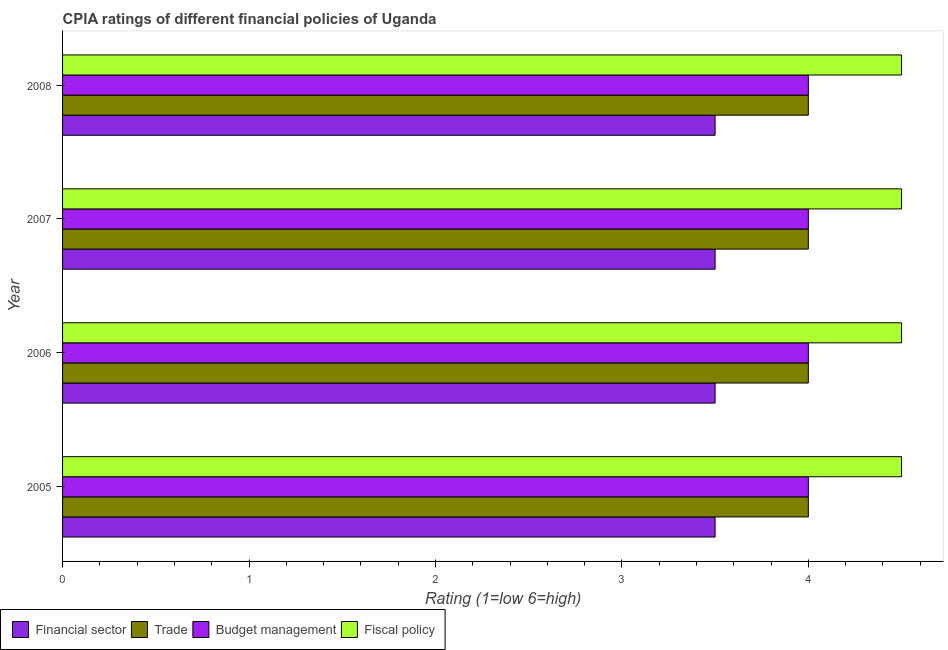How many groups of bars are there?
Offer a very short reply. 4. What is the label of the 2nd group of bars from the top?
Ensure brevity in your answer.  2007. What is the cpia rating of fiscal policy in 2007?
Offer a terse response. 4.5. Across all years, what is the minimum cpia rating of fiscal policy?
Give a very brief answer. 4.5. In which year was the cpia rating of financial sector maximum?
Your response must be concise. 2005. What is the average cpia rating of budget management per year?
Ensure brevity in your answer.  4. In the year 2006, what is the difference between the cpia rating of trade and cpia rating of financial sector?
Provide a succinct answer. 0.5. Is the cpia rating of financial sector in 2005 less than that in 2008?
Your answer should be very brief. No. Is the difference between the cpia rating of financial sector in 2006 and 2008 greater than the difference between the cpia rating of trade in 2006 and 2008?
Your response must be concise. No. What is the difference between the highest and the second highest cpia rating of trade?
Ensure brevity in your answer.  0. In how many years, is the cpia rating of financial sector greater than the average cpia rating of financial sector taken over all years?
Your answer should be compact. 0. What does the 3rd bar from the top in 2005 represents?
Your answer should be compact. Trade. What does the 4th bar from the bottom in 2006 represents?
Offer a terse response. Fiscal policy. How many bars are there?
Your answer should be very brief. 16. Are all the bars in the graph horizontal?
Keep it short and to the point. Yes. How many years are there in the graph?
Offer a very short reply. 4. Does the graph contain any zero values?
Give a very brief answer. No. Where does the legend appear in the graph?
Your answer should be very brief. Bottom left. How many legend labels are there?
Your answer should be compact. 4. How are the legend labels stacked?
Provide a succinct answer. Horizontal. What is the title of the graph?
Provide a short and direct response. CPIA ratings of different financial policies of Uganda. What is the label or title of the X-axis?
Keep it short and to the point. Rating (1=low 6=high). What is the Rating (1=low 6=high) of Financial sector in 2005?
Provide a succinct answer. 3.5. What is the Rating (1=low 6=high) of Budget management in 2005?
Offer a terse response. 4. What is the Rating (1=low 6=high) in Fiscal policy in 2005?
Provide a succinct answer. 4.5. What is the Rating (1=low 6=high) in Financial sector in 2007?
Your response must be concise. 3.5. What is the Rating (1=low 6=high) of Trade in 2007?
Your answer should be very brief. 4. What is the Rating (1=low 6=high) in Fiscal policy in 2007?
Keep it short and to the point. 4.5. What is the Rating (1=low 6=high) in Budget management in 2008?
Provide a short and direct response. 4. What is the Rating (1=low 6=high) in Fiscal policy in 2008?
Give a very brief answer. 4.5. Across all years, what is the maximum Rating (1=low 6=high) of Financial sector?
Your response must be concise. 3.5. Across all years, what is the maximum Rating (1=low 6=high) of Trade?
Make the answer very short. 4. Across all years, what is the maximum Rating (1=low 6=high) of Budget management?
Keep it short and to the point. 4. Across all years, what is the maximum Rating (1=low 6=high) in Fiscal policy?
Your answer should be compact. 4.5. Across all years, what is the minimum Rating (1=low 6=high) in Budget management?
Your response must be concise. 4. Across all years, what is the minimum Rating (1=low 6=high) in Fiscal policy?
Make the answer very short. 4.5. What is the total Rating (1=low 6=high) in Budget management in the graph?
Your response must be concise. 16. What is the total Rating (1=low 6=high) of Fiscal policy in the graph?
Ensure brevity in your answer.  18. What is the difference between the Rating (1=low 6=high) of Trade in 2005 and that in 2006?
Your response must be concise. 0. What is the difference between the Rating (1=low 6=high) in Budget management in 2005 and that in 2006?
Provide a short and direct response. 0. What is the difference between the Rating (1=low 6=high) of Financial sector in 2005 and that in 2008?
Your answer should be compact. 0. What is the difference between the Rating (1=low 6=high) in Trade in 2005 and that in 2008?
Make the answer very short. 0. What is the difference between the Rating (1=low 6=high) of Budget management in 2005 and that in 2008?
Keep it short and to the point. 0. What is the difference between the Rating (1=low 6=high) in Financial sector in 2006 and that in 2007?
Make the answer very short. 0. What is the difference between the Rating (1=low 6=high) of Trade in 2006 and that in 2007?
Make the answer very short. 0. What is the difference between the Rating (1=low 6=high) in Fiscal policy in 2006 and that in 2007?
Ensure brevity in your answer.  0. What is the difference between the Rating (1=low 6=high) of Budget management in 2006 and that in 2008?
Keep it short and to the point. 0. What is the difference between the Rating (1=low 6=high) in Financial sector in 2007 and that in 2008?
Ensure brevity in your answer.  0. What is the difference between the Rating (1=low 6=high) of Budget management in 2007 and that in 2008?
Provide a short and direct response. 0. What is the difference between the Rating (1=low 6=high) in Fiscal policy in 2007 and that in 2008?
Ensure brevity in your answer.  0. What is the difference between the Rating (1=low 6=high) in Financial sector in 2005 and the Rating (1=low 6=high) in Fiscal policy in 2006?
Make the answer very short. -1. What is the difference between the Rating (1=low 6=high) in Budget management in 2005 and the Rating (1=low 6=high) in Fiscal policy in 2006?
Give a very brief answer. -0.5. What is the difference between the Rating (1=low 6=high) of Financial sector in 2005 and the Rating (1=low 6=high) of Budget management in 2007?
Your answer should be compact. -0.5. What is the difference between the Rating (1=low 6=high) of Budget management in 2005 and the Rating (1=low 6=high) of Fiscal policy in 2007?
Keep it short and to the point. -0.5. What is the difference between the Rating (1=low 6=high) in Financial sector in 2005 and the Rating (1=low 6=high) in Trade in 2008?
Your answer should be very brief. -0.5. What is the difference between the Rating (1=low 6=high) of Financial sector in 2005 and the Rating (1=low 6=high) of Budget management in 2008?
Ensure brevity in your answer.  -0.5. What is the difference between the Rating (1=low 6=high) of Financial sector in 2005 and the Rating (1=low 6=high) of Fiscal policy in 2008?
Give a very brief answer. -1. What is the difference between the Rating (1=low 6=high) of Trade in 2005 and the Rating (1=low 6=high) of Fiscal policy in 2008?
Provide a short and direct response. -0.5. What is the difference between the Rating (1=low 6=high) in Financial sector in 2006 and the Rating (1=low 6=high) in Trade in 2007?
Make the answer very short. -0.5. What is the difference between the Rating (1=low 6=high) in Financial sector in 2006 and the Rating (1=low 6=high) in Budget management in 2007?
Offer a terse response. -0.5. What is the difference between the Rating (1=low 6=high) in Trade in 2006 and the Rating (1=low 6=high) in Budget management in 2007?
Provide a succinct answer. 0. What is the difference between the Rating (1=low 6=high) in Trade in 2006 and the Rating (1=low 6=high) in Fiscal policy in 2007?
Your response must be concise. -0.5. What is the difference between the Rating (1=low 6=high) in Budget management in 2006 and the Rating (1=low 6=high) in Fiscal policy in 2007?
Offer a terse response. -0.5. What is the difference between the Rating (1=low 6=high) of Financial sector in 2006 and the Rating (1=low 6=high) of Trade in 2008?
Your answer should be compact. -0.5. What is the difference between the Rating (1=low 6=high) of Financial sector in 2006 and the Rating (1=low 6=high) of Budget management in 2008?
Offer a very short reply. -0.5. What is the difference between the Rating (1=low 6=high) in Financial sector in 2006 and the Rating (1=low 6=high) in Fiscal policy in 2008?
Keep it short and to the point. -1. What is the difference between the Rating (1=low 6=high) of Trade in 2006 and the Rating (1=low 6=high) of Budget management in 2008?
Keep it short and to the point. 0. What is the difference between the Rating (1=low 6=high) of Trade in 2006 and the Rating (1=low 6=high) of Fiscal policy in 2008?
Make the answer very short. -0.5. What is the difference between the Rating (1=low 6=high) in Financial sector in 2007 and the Rating (1=low 6=high) in Budget management in 2008?
Keep it short and to the point. -0.5. What is the difference between the Rating (1=low 6=high) in Financial sector in 2007 and the Rating (1=low 6=high) in Fiscal policy in 2008?
Your answer should be compact. -1. What is the difference between the Rating (1=low 6=high) of Budget management in 2007 and the Rating (1=low 6=high) of Fiscal policy in 2008?
Provide a short and direct response. -0.5. What is the average Rating (1=low 6=high) of Financial sector per year?
Your answer should be compact. 3.5. What is the average Rating (1=low 6=high) of Fiscal policy per year?
Provide a short and direct response. 4.5. In the year 2005, what is the difference between the Rating (1=low 6=high) of Financial sector and Rating (1=low 6=high) of Trade?
Your answer should be very brief. -0.5. In the year 2005, what is the difference between the Rating (1=low 6=high) of Trade and Rating (1=low 6=high) of Budget management?
Ensure brevity in your answer.  0. In the year 2005, what is the difference between the Rating (1=low 6=high) in Trade and Rating (1=low 6=high) in Fiscal policy?
Provide a succinct answer. -0.5. In the year 2005, what is the difference between the Rating (1=low 6=high) of Budget management and Rating (1=low 6=high) of Fiscal policy?
Provide a short and direct response. -0.5. In the year 2006, what is the difference between the Rating (1=low 6=high) in Financial sector and Rating (1=low 6=high) in Trade?
Provide a short and direct response. -0.5. In the year 2006, what is the difference between the Rating (1=low 6=high) in Financial sector and Rating (1=low 6=high) in Fiscal policy?
Your response must be concise. -1. In the year 2006, what is the difference between the Rating (1=low 6=high) of Budget management and Rating (1=low 6=high) of Fiscal policy?
Offer a terse response. -0.5. In the year 2007, what is the difference between the Rating (1=low 6=high) of Financial sector and Rating (1=low 6=high) of Fiscal policy?
Give a very brief answer. -1. In the year 2007, what is the difference between the Rating (1=low 6=high) of Trade and Rating (1=low 6=high) of Fiscal policy?
Your answer should be compact. -0.5. In the year 2008, what is the difference between the Rating (1=low 6=high) in Financial sector and Rating (1=low 6=high) in Trade?
Offer a very short reply. -0.5. In the year 2008, what is the difference between the Rating (1=low 6=high) of Financial sector and Rating (1=low 6=high) of Budget management?
Your answer should be compact. -0.5. In the year 2008, what is the difference between the Rating (1=low 6=high) in Trade and Rating (1=low 6=high) in Budget management?
Keep it short and to the point. 0. In the year 2008, what is the difference between the Rating (1=low 6=high) in Budget management and Rating (1=low 6=high) in Fiscal policy?
Your response must be concise. -0.5. What is the ratio of the Rating (1=low 6=high) of Trade in 2005 to that in 2006?
Offer a very short reply. 1. What is the ratio of the Rating (1=low 6=high) in Fiscal policy in 2005 to that in 2006?
Offer a terse response. 1. What is the ratio of the Rating (1=low 6=high) of Trade in 2005 to that in 2007?
Your answer should be compact. 1. What is the ratio of the Rating (1=low 6=high) of Budget management in 2005 to that in 2007?
Your response must be concise. 1. What is the ratio of the Rating (1=low 6=high) in Fiscal policy in 2005 to that in 2007?
Give a very brief answer. 1. What is the ratio of the Rating (1=low 6=high) of Financial sector in 2005 to that in 2008?
Offer a very short reply. 1. What is the ratio of the Rating (1=low 6=high) in Budget management in 2005 to that in 2008?
Ensure brevity in your answer.  1. What is the ratio of the Rating (1=low 6=high) in Budget management in 2006 to that in 2007?
Keep it short and to the point. 1. What is the ratio of the Rating (1=low 6=high) in Fiscal policy in 2006 to that in 2007?
Your response must be concise. 1. What is the ratio of the Rating (1=low 6=high) in Trade in 2006 to that in 2008?
Provide a succinct answer. 1. What is the ratio of the Rating (1=low 6=high) of Budget management in 2006 to that in 2008?
Give a very brief answer. 1. What is the ratio of the Rating (1=low 6=high) of Fiscal policy in 2006 to that in 2008?
Ensure brevity in your answer.  1. What is the ratio of the Rating (1=low 6=high) in Fiscal policy in 2007 to that in 2008?
Ensure brevity in your answer.  1. What is the difference between the highest and the second highest Rating (1=low 6=high) in Budget management?
Provide a succinct answer. 0. What is the difference between the highest and the lowest Rating (1=low 6=high) of Financial sector?
Provide a succinct answer. 0. What is the difference between the highest and the lowest Rating (1=low 6=high) of Fiscal policy?
Ensure brevity in your answer.  0. 